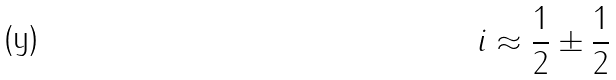<formula> <loc_0><loc_0><loc_500><loc_500>i \approx \frac { 1 } { 2 } \pm \frac { 1 } { 2 }</formula> 